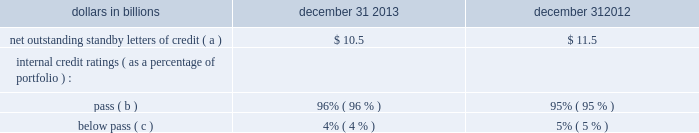2022 through the u.s .
Attorney 2019s office for the district of maryland , the office of the inspector general ( 201coig 201d ) for the small business administration ( 201csba 201d ) has served a subpoena on pnc requesting documents concerning pnc 2019s relationship with , including sba-guaranteed loans made through , a broker named jade capital investments , llc ( 201cjade 201d ) , as well as information regarding other pnc-originated sba guaranteed loans made to businesses located in the state of maryland , the commonwealth of virginia , and washington , dc .
Certain of the jade loans have been identified in an indictment and subsequent superseding indictment charging persons associated with jade with conspiracy to commit bank fraud , substantive violations of the federal bank fraud statute , and money laundering .
Pnc is cooperating with the u.s .
Attorney 2019s office for the district of maryland .
Our practice is to cooperate fully with regulatory and governmental investigations , audits and other inquiries , including those described in this note 23 .
In addition to the proceedings or other matters described above , pnc and persons to whom we may have indemnification obligations , in the normal course of business , are subject to various other pending and threatened legal proceedings in which claims for monetary damages and other relief are asserted .
We do not anticipate , at the present time , that the ultimate aggregate liability , if any , arising out of such other legal proceedings will have a material adverse effect on our financial position .
However , we cannot now determine whether or not any claims asserted against us or others to whom we may have indemnification obligations , whether in the proceedings or other matters described above or otherwise , will have a material adverse effect on our results of operations in any future reporting period , which will depend on , among other things , the amount of the loss resulting from the claim and the amount of income otherwise reported for the reporting period .
See note 24 commitments and guarantees for additional information regarding the visa indemnification and our other obligations to provide indemnification , including to current and former officers , directors , employees and agents of pnc and companies we have acquired .
Note 24 commitments and guarantees equity funding and other commitments our unfunded commitments at december 31 , 2013 included private equity investments of $ 164 million .
Standby letters of credit we issue standby letters of credit and have risk participations in standby letters of credit issued by other financial institutions , in each case to support obligations of our customers to third parties , such as insurance requirements and the facilitation of transactions involving capital markets product execution .
Net outstanding standby letters of credit and internal credit ratings were as follows : table 151 : net outstanding standby letters of credit dollars in billions december 31 december 31 net outstanding standby letters of credit ( a ) $ 10.5 $ 11.5 internal credit ratings ( as a percentage of portfolio ) : .
( a ) the amounts above exclude participations in standby letters of credit of $ 3.3 billion and $ 3.2 billion to other financial institutions as of december 31 , 2013 and december 31 , 2012 , respectively .
The amounts above include $ 6.6 billion and $ 7.5 billion which support remarketing programs at december 31 , 2013 and december 31 , 2012 , respectively .
( b ) indicates that expected risk of loss is currently low .
( c ) indicates a higher degree of risk of default .
If the customer fails to meet its financial or performance obligation to the third party under the terms of the contract or there is a need to support a remarketing program , then upon a draw by a beneficiary , subject to the terms of the letter of credit , we would be obligated to make payment to them .
The standby letters of credit outstanding on december 31 , 2013 had terms ranging from less than 1 year to 6 years .
As of december 31 , 2013 , assets of $ 2.0 billion secured certain specifically identified standby letters of credit .
In addition , a portion of the remaining standby letters of credit issued on behalf of specific customers is also secured by collateral or guarantees that secure the customers 2019 other obligations to us .
The carrying amount of the liability for our obligations related to standby letters of credit and participations in standby letters of credit was $ 218 million at december 31 , 2013 .
Standby bond purchase agreements and other liquidity facilities we enter into standby bond purchase agreements to support municipal bond obligations .
At december 31 , 2013 , the aggregate of our commitments under these facilities was $ 1.3 billion .
We also enter into certain other liquidity facilities to support individual pools of receivables acquired by commercial paper conduits .
There were no commitments under these facilities at december 31 , 2013 .
212 the pnc financial services group , inc .
2013 form 10-k .
If you include the balance of standby letters of credit to other financial institutions as of december 31 , 2013 , what would be the balance in billions of net outstanding standby letters of credit ? 
Computations: (10.5 + 3.3)
Answer: 13.8. 